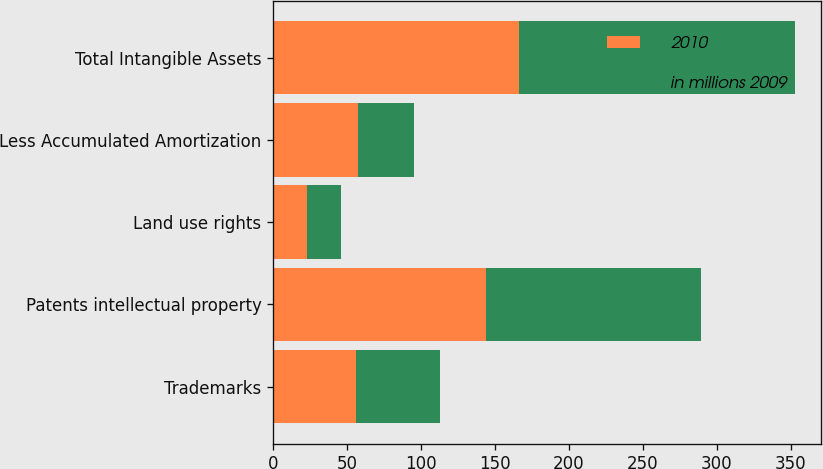<chart> <loc_0><loc_0><loc_500><loc_500><stacked_bar_chart><ecel><fcel>Trademarks<fcel>Patents intellectual property<fcel>Land use rights<fcel>Less Accumulated Amortization<fcel>Total Intangible Assets<nl><fcel>2010<fcel>56<fcel>144<fcel>23<fcel>57<fcel>166<nl><fcel>in millions 2009<fcel>57<fcel>145<fcel>23<fcel>38<fcel>187<nl></chart> 